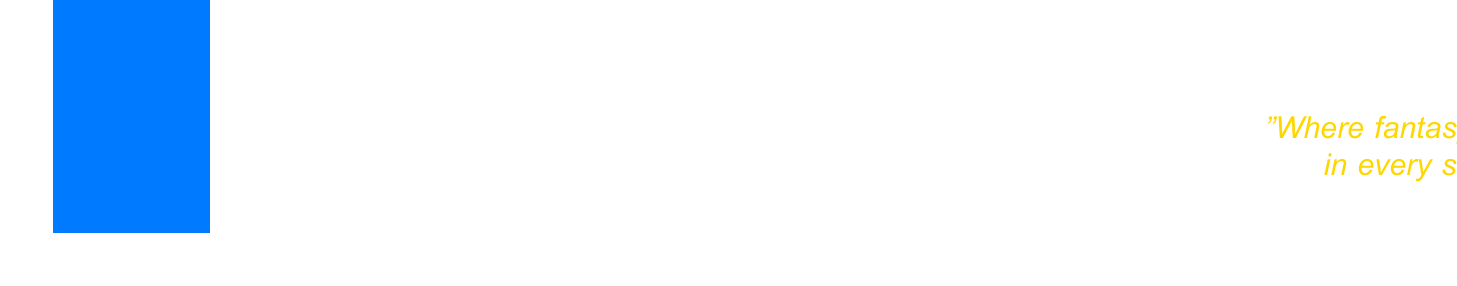What is the total revenue projection? The total revenue projection is clearly stated in the revenue projection section of the document.
Answer: $15.2 million What is the profit margin for FantasyMerch Inc.? The profit margin is explicitly mentioned in the financial forecast.
Answer: 28.9% How much is projected for accessories revenue? The revenue for accessories is listed under the revenue breakdown.
Answer: $4.3 million What are the top selling products? The document lists the top selling products clearly in a separate section.
Answer: NFL Fantasy League Champion Trophy, Custom MLB Team Manager Jersey, NBA Fantasy Draft Party Kit What are the major categories of operating expenses? The document provides a breakdown of operating expenses into major categories.
Answer: Production, Marketing, R&D, Administrative What is the expected growth rate year-over-year? The expected growth rate can be found in the revenue projection section of the document.
Answer: 12% year-over-year What new product lines are introduced? New product lines are clearly listed in a section dedicated to them in the document.
Answer: E-sports Fantasy Merchandise, Augmented Reality Fantasy Gear Which partnerships are emphasized in this forecast? The document mentions the key partnerships in a specific section.
Answer: ESPN Fantasy, DraftKings, FanDuel What risk factors are identified? The risk factors are outlined in a dedicated section of the financial report.
Answer: Potential changes in fantasy sports regulations, Supply chain disruptions, Increased competition from major sports retailers 